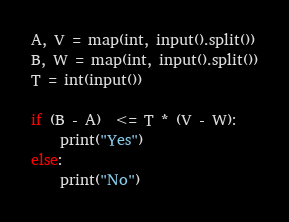Convert code to text. <code><loc_0><loc_0><loc_500><loc_500><_Python_>A, V = map(int, input().split())
B, W = map(int, input().split())
T = int(input())

if (B - A)  <= T * (V - W):
    print("Yes")
else:
    print("No")</code> 